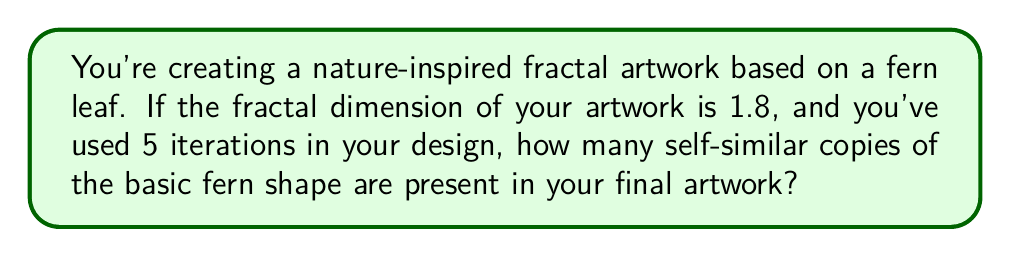What is the answer to this math problem? Let's approach this step-by-step:

1) The fractal dimension (D) is related to the number of self-similar pieces (N) and the scaling factor (r) by the equation:

   $$D = \frac{\log N}{\log(1/r)}$$

2) We're given that D = 1.8, and we need to find N after 5 iterations.

3) For each iteration, the number of copies increases by a factor of N. So after 5 iterations, the total number of copies is $N^5$.

4) We don't know the scaling factor r, but we can eliminate it from our calculations:

   $$1.8 = \frac{\log N}{\log(1/r)}$$

5) Rearranging this:

   $$\log N = 1.8 \log(1/r)$$

6) Taking the antilog of both sides:

   $$N = (1/r)^{1.8}$$

7) Now, the total number of copies after 5 iterations is:

   $$N^5 = ((1/r)^{1.8})^5 = (1/r)^9$$

8) This means that after 5 iterations, the number of copies is equivalent to what you'd get from a single iteration with a fractal dimension of 9.

9) To find this number, we can use the nearest whole number:

   $$N \approx 2^9 = 512$$

This approximation is reasonable because most natural fractals, like ferns, have a branching factor close to 2.
Answer: 512 self-similar copies 